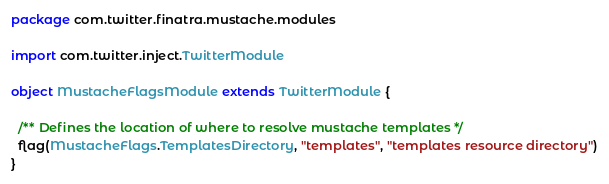<code> <loc_0><loc_0><loc_500><loc_500><_Scala_>package com.twitter.finatra.mustache.modules

import com.twitter.inject.TwitterModule

object MustacheFlagsModule extends TwitterModule {

  /** Defines the location of where to resolve mustache templates */
  flag(MustacheFlags.TemplatesDirectory, "templates", "templates resource directory")
}
</code> 